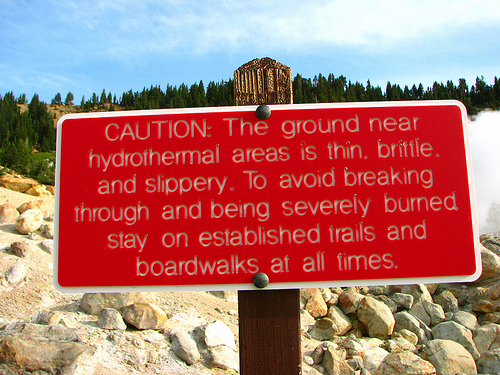<image>
Is the sign on the trees? No. The sign is not positioned on the trees. They may be near each other, but the sign is not supported by or resting on top of the trees. Is there a caution above the rocks? Yes. The caution is positioned above the rocks in the vertical space, higher up in the scene. 